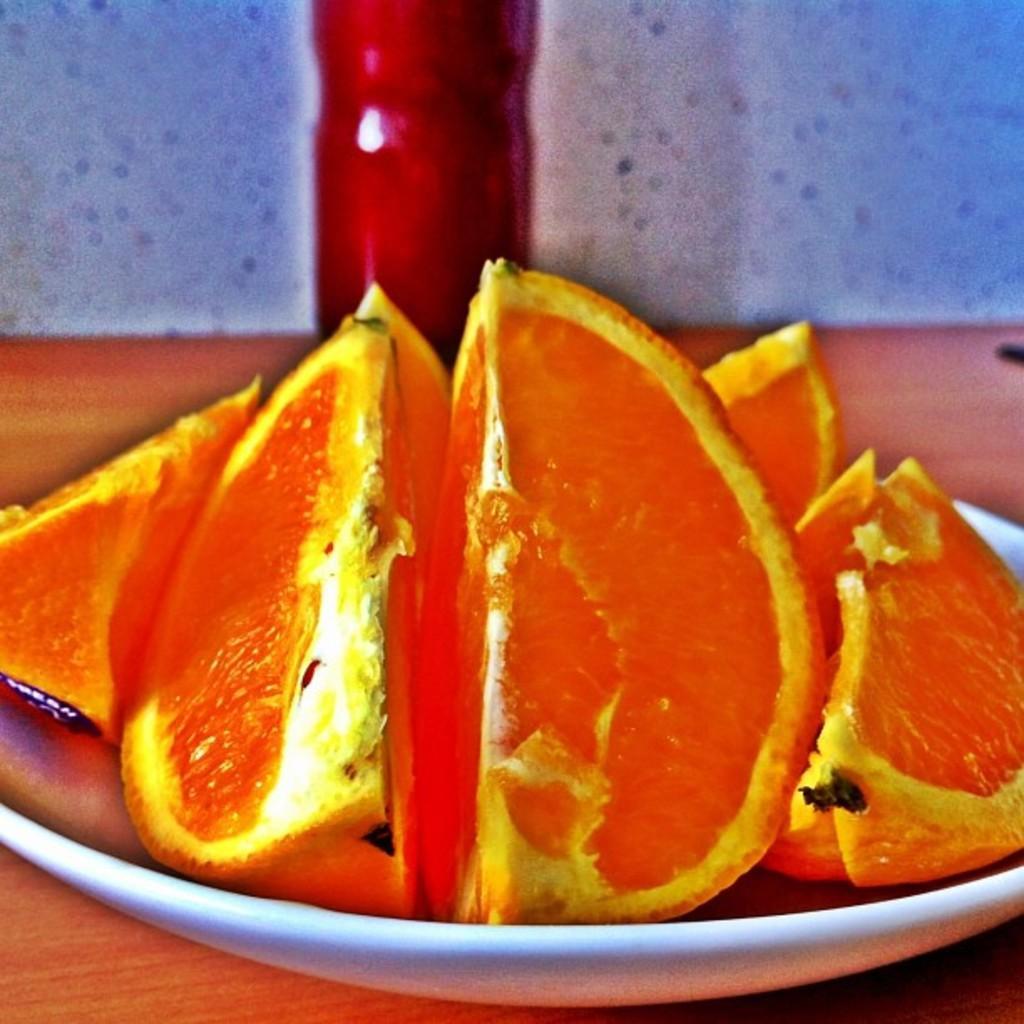Could you give a brief overview of what you see in this image? In the center of the image we can see a plate containing orange slices and a bottle placed on the table. In the background there is a wall. 